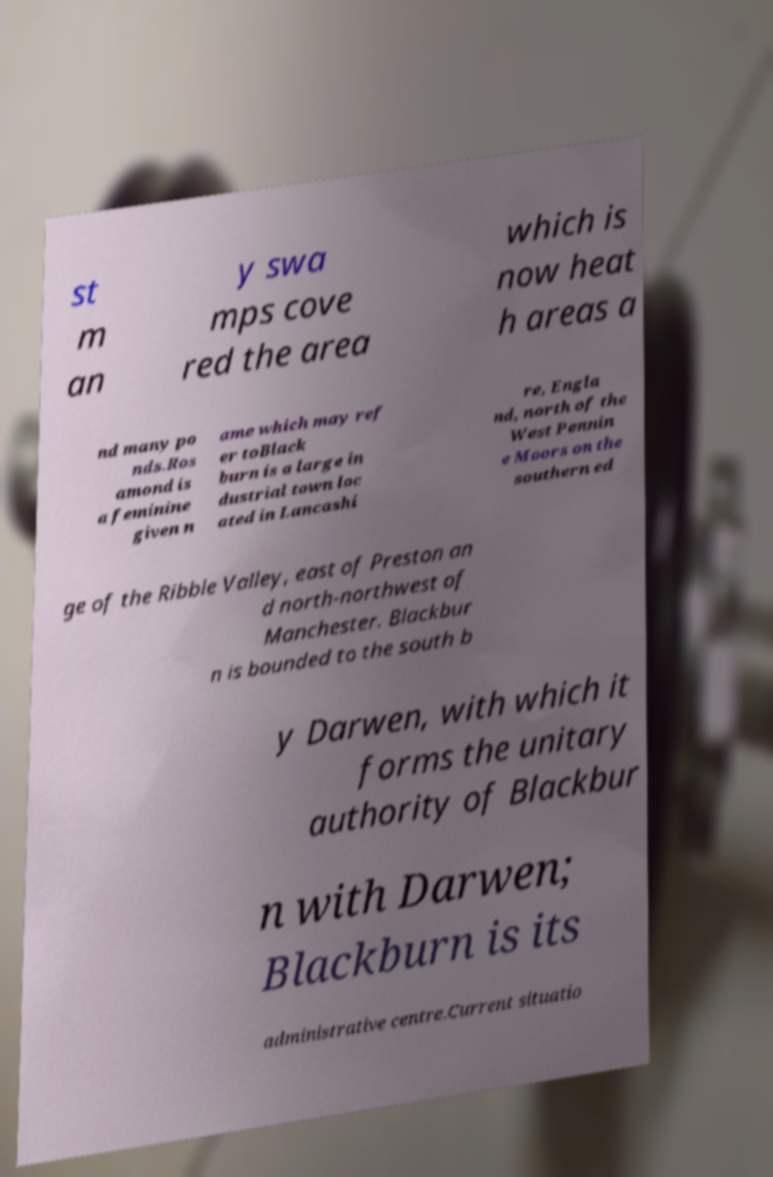Please identify and transcribe the text found in this image. st m an y swa mps cove red the area which is now heat h areas a nd many po nds.Ros amond is a feminine given n ame which may ref er toBlack burn is a large in dustrial town loc ated in Lancashi re, Engla nd, north of the West Pennin e Moors on the southern ed ge of the Ribble Valley, east of Preston an d north-northwest of Manchester. Blackbur n is bounded to the south b y Darwen, with which it forms the unitary authority of Blackbur n with Darwen; Blackburn is its administrative centre.Current situatio 